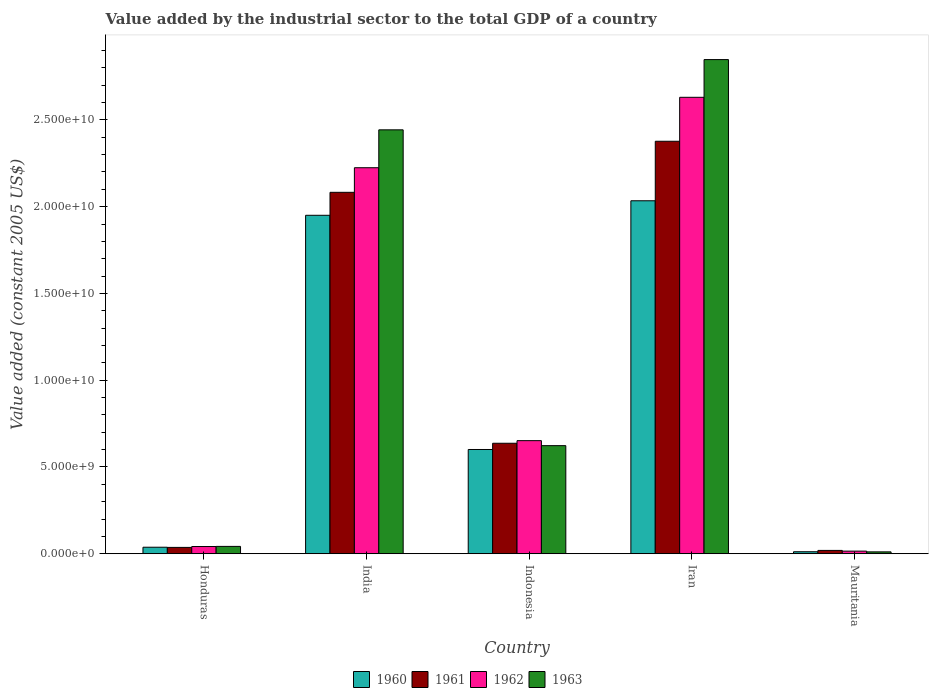How many groups of bars are there?
Provide a succinct answer. 5. Are the number of bars per tick equal to the number of legend labels?
Give a very brief answer. Yes. In how many cases, is the number of bars for a given country not equal to the number of legend labels?
Ensure brevity in your answer.  0. What is the value added by the industrial sector in 1961 in Iran?
Offer a very short reply. 2.38e+1. Across all countries, what is the maximum value added by the industrial sector in 1963?
Your answer should be compact. 2.85e+1. Across all countries, what is the minimum value added by the industrial sector in 1961?
Give a very brief answer. 1.92e+08. In which country was the value added by the industrial sector in 1963 maximum?
Keep it short and to the point. Iran. In which country was the value added by the industrial sector in 1963 minimum?
Offer a very short reply. Mauritania. What is the total value added by the industrial sector in 1962 in the graph?
Make the answer very short. 5.56e+1. What is the difference between the value added by the industrial sector in 1963 in India and that in Indonesia?
Ensure brevity in your answer.  1.82e+1. What is the difference between the value added by the industrial sector in 1961 in Indonesia and the value added by the industrial sector in 1960 in Iran?
Your response must be concise. -1.40e+1. What is the average value added by the industrial sector in 1961 per country?
Provide a short and direct response. 1.03e+1. What is the difference between the value added by the industrial sector of/in 1960 and value added by the industrial sector of/in 1961 in Honduras?
Your answer should be very brief. 9.37e+06. What is the ratio of the value added by the industrial sector in 1962 in Honduras to that in India?
Give a very brief answer. 0.02. What is the difference between the highest and the second highest value added by the industrial sector in 1961?
Offer a very short reply. -2.94e+09. What is the difference between the highest and the lowest value added by the industrial sector in 1963?
Give a very brief answer. 2.84e+1. Is the sum of the value added by the industrial sector in 1962 in Honduras and Iran greater than the maximum value added by the industrial sector in 1961 across all countries?
Make the answer very short. Yes. Is it the case that in every country, the sum of the value added by the industrial sector in 1961 and value added by the industrial sector in 1960 is greater than the sum of value added by the industrial sector in 1962 and value added by the industrial sector in 1963?
Make the answer very short. No. How many bars are there?
Your answer should be very brief. 20. Are the values on the major ticks of Y-axis written in scientific E-notation?
Give a very brief answer. Yes. Does the graph contain grids?
Provide a short and direct response. No. How many legend labels are there?
Ensure brevity in your answer.  4. What is the title of the graph?
Provide a short and direct response. Value added by the industrial sector to the total GDP of a country. What is the label or title of the X-axis?
Keep it short and to the point. Country. What is the label or title of the Y-axis?
Keep it short and to the point. Value added (constant 2005 US$). What is the Value added (constant 2005 US$) of 1960 in Honduras?
Your answer should be compact. 3.75e+08. What is the Value added (constant 2005 US$) of 1961 in Honduras?
Ensure brevity in your answer.  3.66e+08. What is the Value added (constant 2005 US$) in 1962 in Honduras?
Ensure brevity in your answer.  4.16e+08. What is the Value added (constant 2005 US$) of 1963 in Honduras?
Provide a short and direct response. 4.23e+08. What is the Value added (constant 2005 US$) in 1960 in India?
Your answer should be very brief. 1.95e+1. What is the Value added (constant 2005 US$) in 1961 in India?
Offer a very short reply. 2.08e+1. What is the Value added (constant 2005 US$) in 1962 in India?
Offer a very short reply. 2.22e+1. What is the Value added (constant 2005 US$) in 1963 in India?
Make the answer very short. 2.44e+1. What is the Value added (constant 2005 US$) of 1960 in Indonesia?
Provide a succinct answer. 6.01e+09. What is the Value added (constant 2005 US$) of 1961 in Indonesia?
Ensure brevity in your answer.  6.37e+09. What is the Value added (constant 2005 US$) in 1962 in Indonesia?
Provide a succinct answer. 6.52e+09. What is the Value added (constant 2005 US$) of 1963 in Indonesia?
Give a very brief answer. 6.23e+09. What is the Value added (constant 2005 US$) in 1960 in Iran?
Your response must be concise. 2.03e+1. What is the Value added (constant 2005 US$) in 1961 in Iran?
Provide a succinct answer. 2.38e+1. What is the Value added (constant 2005 US$) of 1962 in Iran?
Ensure brevity in your answer.  2.63e+1. What is the Value added (constant 2005 US$) of 1963 in Iran?
Keep it short and to the point. 2.85e+1. What is the Value added (constant 2005 US$) in 1960 in Mauritania?
Provide a short and direct response. 1.15e+08. What is the Value added (constant 2005 US$) in 1961 in Mauritania?
Ensure brevity in your answer.  1.92e+08. What is the Value added (constant 2005 US$) of 1962 in Mauritania?
Your answer should be very brief. 1.51e+08. What is the Value added (constant 2005 US$) in 1963 in Mauritania?
Your answer should be very brief. 1.08e+08. Across all countries, what is the maximum Value added (constant 2005 US$) in 1960?
Provide a short and direct response. 2.03e+1. Across all countries, what is the maximum Value added (constant 2005 US$) of 1961?
Your response must be concise. 2.38e+1. Across all countries, what is the maximum Value added (constant 2005 US$) of 1962?
Keep it short and to the point. 2.63e+1. Across all countries, what is the maximum Value added (constant 2005 US$) in 1963?
Make the answer very short. 2.85e+1. Across all countries, what is the minimum Value added (constant 2005 US$) in 1960?
Your answer should be compact. 1.15e+08. Across all countries, what is the minimum Value added (constant 2005 US$) of 1961?
Provide a succinct answer. 1.92e+08. Across all countries, what is the minimum Value added (constant 2005 US$) in 1962?
Provide a short and direct response. 1.51e+08. Across all countries, what is the minimum Value added (constant 2005 US$) of 1963?
Keep it short and to the point. 1.08e+08. What is the total Value added (constant 2005 US$) in 1960 in the graph?
Offer a terse response. 4.63e+1. What is the total Value added (constant 2005 US$) of 1961 in the graph?
Offer a terse response. 5.15e+1. What is the total Value added (constant 2005 US$) of 1962 in the graph?
Make the answer very short. 5.56e+1. What is the total Value added (constant 2005 US$) of 1963 in the graph?
Provide a short and direct response. 5.97e+1. What is the difference between the Value added (constant 2005 US$) of 1960 in Honduras and that in India?
Your answer should be very brief. -1.91e+1. What is the difference between the Value added (constant 2005 US$) of 1961 in Honduras and that in India?
Offer a very short reply. -2.05e+1. What is the difference between the Value added (constant 2005 US$) of 1962 in Honduras and that in India?
Provide a short and direct response. -2.18e+1. What is the difference between the Value added (constant 2005 US$) of 1963 in Honduras and that in India?
Your answer should be very brief. -2.40e+1. What is the difference between the Value added (constant 2005 US$) of 1960 in Honduras and that in Indonesia?
Give a very brief answer. -5.63e+09. What is the difference between the Value added (constant 2005 US$) in 1961 in Honduras and that in Indonesia?
Your answer should be compact. -6.00e+09. What is the difference between the Value added (constant 2005 US$) in 1962 in Honduras and that in Indonesia?
Provide a short and direct response. -6.10e+09. What is the difference between the Value added (constant 2005 US$) of 1963 in Honduras and that in Indonesia?
Keep it short and to the point. -5.81e+09. What is the difference between the Value added (constant 2005 US$) of 1960 in Honduras and that in Iran?
Give a very brief answer. -2.00e+1. What is the difference between the Value added (constant 2005 US$) of 1961 in Honduras and that in Iran?
Your response must be concise. -2.34e+1. What is the difference between the Value added (constant 2005 US$) in 1962 in Honduras and that in Iran?
Your answer should be compact. -2.59e+1. What is the difference between the Value added (constant 2005 US$) in 1963 in Honduras and that in Iran?
Provide a succinct answer. -2.81e+1. What is the difference between the Value added (constant 2005 US$) in 1960 in Honduras and that in Mauritania?
Provide a succinct answer. 2.60e+08. What is the difference between the Value added (constant 2005 US$) in 1961 in Honduras and that in Mauritania?
Your answer should be very brief. 1.74e+08. What is the difference between the Value added (constant 2005 US$) of 1962 in Honduras and that in Mauritania?
Your response must be concise. 2.65e+08. What is the difference between the Value added (constant 2005 US$) of 1963 in Honduras and that in Mauritania?
Offer a very short reply. 3.15e+08. What is the difference between the Value added (constant 2005 US$) of 1960 in India and that in Indonesia?
Your answer should be very brief. 1.35e+1. What is the difference between the Value added (constant 2005 US$) in 1961 in India and that in Indonesia?
Keep it short and to the point. 1.45e+1. What is the difference between the Value added (constant 2005 US$) in 1962 in India and that in Indonesia?
Give a very brief answer. 1.57e+1. What is the difference between the Value added (constant 2005 US$) of 1963 in India and that in Indonesia?
Your answer should be compact. 1.82e+1. What is the difference between the Value added (constant 2005 US$) in 1960 in India and that in Iran?
Your answer should be compact. -8.36e+08. What is the difference between the Value added (constant 2005 US$) in 1961 in India and that in Iran?
Your answer should be very brief. -2.94e+09. What is the difference between the Value added (constant 2005 US$) in 1962 in India and that in Iran?
Ensure brevity in your answer.  -4.06e+09. What is the difference between the Value added (constant 2005 US$) of 1963 in India and that in Iran?
Offer a terse response. -4.05e+09. What is the difference between the Value added (constant 2005 US$) of 1960 in India and that in Mauritania?
Offer a very short reply. 1.94e+1. What is the difference between the Value added (constant 2005 US$) of 1961 in India and that in Mauritania?
Make the answer very short. 2.06e+1. What is the difference between the Value added (constant 2005 US$) of 1962 in India and that in Mauritania?
Offer a terse response. 2.21e+1. What is the difference between the Value added (constant 2005 US$) of 1963 in India and that in Mauritania?
Provide a succinct answer. 2.43e+1. What is the difference between the Value added (constant 2005 US$) of 1960 in Indonesia and that in Iran?
Make the answer very short. -1.43e+1. What is the difference between the Value added (constant 2005 US$) of 1961 in Indonesia and that in Iran?
Ensure brevity in your answer.  -1.74e+1. What is the difference between the Value added (constant 2005 US$) in 1962 in Indonesia and that in Iran?
Your answer should be compact. -1.98e+1. What is the difference between the Value added (constant 2005 US$) in 1963 in Indonesia and that in Iran?
Provide a short and direct response. -2.22e+1. What is the difference between the Value added (constant 2005 US$) of 1960 in Indonesia and that in Mauritania?
Your response must be concise. 5.89e+09. What is the difference between the Value added (constant 2005 US$) of 1961 in Indonesia and that in Mauritania?
Make the answer very short. 6.17e+09. What is the difference between the Value added (constant 2005 US$) in 1962 in Indonesia and that in Mauritania?
Your answer should be very brief. 6.37e+09. What is the difference between the Value added (constant 2005 US$) in 1963 in Indonesia and that in Mauritania?
Your response must be concise. 6.12e+09. What is the difference between the Value added (constant 2005 US$) of 1960 in Iran and that in Mauritania?
Your answer should be very brief. 2.02e+1. What is the difference between the Value added (constant 2005 US$) of 1961 in Iran and that in Mauritania?
Ensure brevity in your answer.  2.36e+1. What is the difference between the Value added (constant 2005 US$) in 1962 in Iran and that in Mauritania?
Provide a short and direct response. 2.62e+1. What is the difference between the Value added (constant 2005 US$) of 1963 in Iran and that in Mauritania?
Ensure brevity in your answer.  2.84e+1. What is the difference between the Value added (constant 2005 US$) of 1960 in Honduras and the Value added (constant 2005 US$) of 1961 in India?
Your response must be concise. -2.05e+1. What is the difference between the Value added (constant 2005 US$) of 1960 in Honduras and the Value added (constant 2005 US$) of 1962 in India?
Provide a succinct answer. -2.19e+1. What is the difference between the Value added (constant 2005 US$) of 1960 in Honduras and the Value added (constant 2005 US$) of 1963 in India?
Keep it short and to the point. -2.41e+1. What is the difference between the Value added (constant 2005 US$) in 1961 in Honduras and the Value added (constant 2005 US$) in 1962 in India?
Offer a very short reply. -2.19e+1. What is the difference between the Value added (constant 2005 US$) in 1961 in Honduras and the Value added (constant 2005 US$) in 1963 in India?
Keep it short and to the point. -2.41e+1. What is the difference between the Value added (constant 2005 US$) of 1962 in Honduras and the Value added (constant 2005 US$) of 1963 in India?
Ensure brevity in your answer.  -2.40e+1. What is the difference between the Value added (constant 2005 US$) of 1960 in Honduras and the Value added (constant 2005 US$) of 1961 in Indonesia?
Your response must be concise. -5.99e+09. What is the difference between the Value added (constant 2005 US$) of 1960 in Honduras and the Value added (constant 2005 US$) of 1962 in Indonesia?
Provide a succinct answer. -6.14e+09. What is the difference between the Value added (constant 2005 US$) in 1960 in Honduras and the Value added (constant 2005 US$) in 1963 in Indonesia?
Keep it short and to the point. -5.85e+09. What is the difference between the Value added (constant 2005 US$) in 1961 in Honduras and the Value added (constant 2005 US$) in 1962 in Indonesia?
Your answer should be compact. -6.15e+09. What is the difference between the Value added (constant 2005 US$) in 1961 in Honduras and the Value added (constant 2005 US$) in 1963 in Indonesia?
Your response must be concise. -5.86e+09. What is the difference between the Value added (constant 2005 US$) of 1962 in Honduras and the Value added (constant 2005 US$) of 1963 in Indonesia?
Your answer should be very brief. -5.81e+09. What is the difference between the Value added (constant 2005 US$) of 1960 in Honduras and the Value added (constant 2005 US$) of 1961 in Iran?
Your response must be concise. -2.34e+1. What is the difference between the Value added (constant 2005 US$) of 1960 in Honduras and the Value added (constant 2005 US$) of 1962 in Iran?
Your answer should be compact. -2.59e+1. What is the difference between the Value added (constant 2005 US$) of 1960 in Honduras and the Value added (constant 2005 US$) of 1963 in Iran?
Offer a terse response. -2.81e+1. What is the difference between the Value added (constant 2005 US$) of 1961 in Honduras and the Value added (constant 2005 US$) of 1962 in Iran?
Give a very brief answer. -2.59e+1. What is the difference between the Value added (constant 2005 US$) in 1961 in Honduras and the Value added (constant 2005 US$) in 1963 in Iran?
Give a very brief answer. -2.81e+1. What is the difference between the Value added (constant 2005 US$) of 1962 in Honduras and the Value added (constant 2005 US$) of 1963 in Iran?
Offer a terse response. -2.81e+1. What is the difference between the Value added (constant 2005 US$) in 1960 in Honduras and the Value added (constant 2005 US$) in 1961 in Mauritania?
Keep it short and to the point. 1.83e+08. What is the difference between the Value added (constant 2005 US$) in 1960 in Honduras and the Value added (constant 2005 US$) in 1962 in Mauritania?
Offer a very short reply. 2.24e+08. What is the difference between the Value added (constant 2005 US$) in 1960 in Honduras and the Value added (constant 2005 US$) in 1963 in Mauritania?
Your answer should be compact. 2.67e+08. What is the difference between the Value added (constant 2005 US$) of 1961 in Honduras and the Value added (constant 2005 US$) of 1962 in Mauritania?
Keep it short and to the point. 2.15e+08. What is the difference between the Value added (constant 2005 US$) in 1961 in Honduras and the Value added (constant 2005 US$) in 1963 in Mauritania?
Your answer should be compact. 2.58e+08. What is the difference between the Value added (constant 2005 US$) in 1962 in Honduras and the Value added (constant 2005 US$) in 1963 in Mauritania?
Make the answer very short. 3.08e+08. What is the difference between the Value added (constant 2005 US$) in 1960 in India and the Value added (constant 2005 US$) in 1961 in Indonesia?
Give a very brief answer. 1.31e+1. What is the difference between the Value added (constant 2005 US$) in 1960 in India and the Value added (constant 2005 US$) in 1962 in Indonesia?
Provide a succinct answer. 1.30e+1. What is the difference between the Value added (constant 2005 US$) in 1960 in India and the Value added (constant 2005 US$) in 1963 in Indonesia?
Keep it short and to the point. 1.33e+1. What is the difference between the Value added (constant 2005 US$) of 1961 in India and the Value added (constant 2005 US$) of 1962 in Indonesia?
Give a very brief answer. 1.43e+1. What is the difference between the Value added (constant 2005 US$) of 1961 in India and the Value added (constant 2005 US$) of 1963 in Indonesia?
Provide a succinct answer. 1.46e+1. What is the difference between the Value added (constant 2005 US$) of 1962 in India and the Value added (constant 2005 US$) of 1963 in Indonesia?
Your response must be concise. 1.60e+1. What is the difference between the Value added (constant 2005 US$) in 1960 in India and the Value added (constant 2005 US$) in 1961 in Iran?
Keep it short and to the point. -4.27e+09. What is the difference between the Value added (constant 2005 US$) of 1960 in India and the Value added (constant 2005 US$) of 1962 in Iran?
Offer a very short reply. -6.80e+09. What is the difference between the Value added (constant 2005 US$) in 1960 in India and the Value added (constant 2005 US$) in 1963 in Iran?
Your answer should be compact. -8.97e+09. What is the difference between the Value added (constant 2005 US$) of 1961 in India and the Value added (constant 2005 US$) of 1962 in Iran?
Provide a succinct answer. -5.48e+09. What is the difference between the Value added (constant 2005 US$) of 1961 in India and the Value added (constant 2005 US$) of 1963 in Iran?
Provide a short and direct response. -7.65e+09. What is the difference between the Value added (constant 2005 US$) of 1962 in India and the Value added (constant 2005 US$) of 1963 in Iran?
Provide a short and direct response. -6.23e+09. What is the difference between the Value added (constant 2005 US$) of 1960 in India and the Value added (constant 2005 US$) of 1961 in Mauritania?
Offer a very short reply. 1.93e+1. What is the difference between the Value added (constant 2005 US$) in 1960 in India and the Value added (constant 2005 US$) in 1962 in Mauritania?
Ensure brevity in your answer.  1.94e+1. What is the difference between the Value added (constant 2005 US$) of 1960 in India and the Value added (constant 2005 US$) of 1963 in Mauritania?
Ensure brevity in your answer.  1.94e+1. What is the difference between the Value added (constant 2005 US$) in 1961 in India and the Value added (constant 2005 US$) in 1962 in Mauritania?
Make the answer very short. 2.07e+1. What is the difference between the Value added (constant 2005 US$) in 1961 in India and the Value added (constant 2005 US$) in 1963 in Mauritania?
Make the answer very short. 2.07e+1. What is the difference between the Value added (constant 2005 US$) of 1962 in India and the Value added (constant 2005 US$) of 1963 in Mauritania?
Provide a short and direct response. 2.21e+1. What is the difference between the Value added (constant 2005 US$) of 1960 in Indonesia and the Value added (constant 2005 US$) of 1961 in Iran?
Give a very brief answer. -1.78e+1. What is the difference between the Value added (constant 2005 US$) in 1960 in Indonesia and the Value added (constant 2005 US$) in 1962 in Iran?
Provide a succinct answer. -2.03e+1. What is the difference between the Value added (constant 2005 US$) of 1960 in Indonesia and the Value added (constant 2005 US$) of 1963 in Iran?
Offer a terse response. -2.25e+1. What is the difference between the Value added (constant 2005 US$) in 1961 in Indonesia and the Value added (constant 2005 US$) in 1962 in Iran?
Your answer should be very brief. -1.99e+1. What is the difference between the Value added (constant 2005 US$) in 1961 in Indonesia and the Value added (constant 2005 US$) in 1963 in Iran?
Your response must be concise. -2.21e+1. What is the difference between the Value added (constant 2005 US$) of 1962 in Indonesia and the Value added (constant 2005 US$) of 1963 in Iran?
Ensure brevity in your answer.  -2.20e+1. What is the difference between the Value added (constant 2005 US$) of 1960 in Indonesia and the Value added (constant 2005 US$) of 1961 in Mauritania?
Your answer should be compact. 5.81e+09. What is the difference between the Value added (constant 2005 US$) in 1960 in Indonesia and the Value added (constant 2005 US$) in 1962 in Mauritania?
Provide a succinct answer. 5.86e+09. What is the difference between the Value added (constant 2005 US$) of 1960 in Indonesia and the Value added (constant 2005 US$) of 1963 in Mauritania?
Provide a short and direct response. 5.90e+09. What is the difference between the Value added (constant 2005 US$) in 1961 in Indonesia and the Value added (constant 2005 US$) in 1962 in Mauritania?
Your response must be concise. 6.22e+09. What is the difference between the Value added (constant 2005 US$) of 1961 in Indonesia and the Value added (constant 2005 US$) of 1963 in Mauritania?
Your response must be concise. 6.26e+09. What is the difference between the Value added (constant 2005 US$) of 1962 in Indonesia and the Value added (constant 2005 US$) of 1963 in Mauritania?
Provide a short and direct response. 6.41e+09. What is the difference between the Value added (constant 2005 US$) in 1960 in Iran and the Value added (constant 2005 US$) in 1961 in Mauritania?
Your answer should be compact. 2.01e+1. What is the difference between the Value added (constant 2005 US$) in 1960 in Iran and the Value added (constant 2005 US$) in 1962 in Mauritania?
Offer a very short reply. 2.02e+1. What is the difference between the Value added (constant 2005 US$) in 1960 in Iran and the Value added (constant 2005 US$) in 1963 in Mauritania?
Keep it short and to the point. 2.02e+1. What is the difference between the Value added (constant 2005 US$) of 1961 in Iran and the Value added (constant 2005 US$) of 1962 in Mauritania?
Offer a very short reply. 2.36e+1. What is the difference between the Value added (constant 2005 US$) in 1961 in Iran and the Value added (constant 2005 US$) in 1963 in Mauritania?
Make the answer very short. 2.37e+1. What is the difference between the Value added (constant 2005 US$) in 1962 in Iran and the Value added (constant 2005 US$) in 1963 in Mauritania?
Offer a terse response. 2.62e+1. What is the average Value added (constant 2005 US$) in 1960 per country?
Make the answer very short. 9.27e+09. What is the average Value added (constant 2005 US$) in 1961 per country?
Give a very brief answer. 1.03e+1. What is the average Value added (constant 2005 US$) of 1962 per country?
Provide a short and direct response. 1.11e+1. What is the average Value added (constant 2005 US$) of 1963 per country?
Your answer should be very brief. 1.19e+1. What is the difference between the Value added (constant 2005 US$) in 1960 and Value added (constant 2005 US$) in 1961 in Honduras?
Your answer should be compact. 9.37e+06. What is the difference between the Value added (constant 2005 US$) of 1960 and Value added (constant 2005 US$) of 1962 in Honduras?
Your response must be concise. -4.07e+07. What is the difference between the Value added (constant 2005 US$) of 1960 and Value added (constant 2005 US$) of 1963 in Honduras?
Ensure brevity in your answer.  -4.79e+07. What is the difference between the Value added (constant 2005 US$) of 1961 and Value added (constant 2005 US$) of 1962 in Honduras?
Your answer should be very brief. -5.00e+07. What is the difference between the Value added (constant 2005 US$) in 1961 and Value added (constant 2005 US$) in 1963 in Honduras?
Ensure brevity in your answer.  -5.72e+07. What is the difference between the Value added (constant 2005 US$) in 1962 and Value added (constant 2005 US$) in 1963 in Honduras?
Provide a succinct answer. -7.19e+06. What is the difference between the Value added (constant 2005 US$) of 1960 and Value added (constant 2005 US$) of 1961 in India?
Give a very brief answer. -1.32e+09. What is the difference between the Value added (constant 2005 US$) in 1960 and Value added (constant 2005 US$) in 1962 in India?
Your answer should be very brief. -2.74e+09. What is the difference between the Value added (constant 2005 US$) in 1960 and Value added (constant 2005 US$) in 1963 in India?
Your response must be concise. -4.92e+09. What is the difference between the Value added (constant 2005 US$) of 1961 and Value added (constant 2005 US$) of 1962 in India?
Offer a very short reply. -1.42e+09. What is the difference between the Value added (constant 2005 US$) of 1961 and Value added (constant 2005 US$) of 1963 in India?
Keep it short and to the point. -3.60e+09. What is the difference between the Value added (constant 2005 US$) in 1962 and Value added (constant 2005 US$) in 1963 in India?
Ensure brevity in your answer.  -2.18e+09. What is the difference between the Value added (constant 2005 US$) of 1960 and Value added (constant 2005 US$) of 1961 in Indonesia?
Keep it short and to the point. -3.60e+08. What is the difference between the Value added (constant 2005 US$) of 1960 and Value added (constant 2005 US$) of 1962 in Indonesia?
Provide a succinct answer. -5.10e+08. What is the difference between the Value added (constant 2005 US$) of 1960 and Value added (constant 2005 US$) of 1963 in Indonesia?
Offer a very short reply. -2.22e+08. What is the difference between the Value added (constant 2005 US$) of 1961 and Value added (constant 2005 US$) of 1962 in Indonesia?
Provide a succinct answer. -1.50e+08. What is the difference between the Value added (constant 2005 US$) of 1961 and Value added (constant 2005 US$) of 1963 in Indonesia?
Provide a short and direct response. 1.38e+08. What is the difference between the Value added (constant 2005 US$) of 1962 and Value added (constant 2005 US$) of 1963 in Indonesia?
Your response must be concise. 2.88e+08. What is the difference between the Value added (constant 2005 US$) of 1960 and Value added (constant 2005 US$) of 1961 in Iran?
Make the answer very short. -3.43e+09. What is the difference between the Value added (constant 2005 US$) of 1960 and Value added (constant 2005 US$) of 1962 in Iran?
Provide a succinct answer. -5.96e+09. What is the difference between the Value added (constant 2005 US$) of 1960 and Value added (constant 2005 US$) of 1963 in Iran?
Your answer should be very brief. -8.14e+09. What is the difference between the Value added (constant 2005 US$) in 1961 and Value added (constant 2005 US$) in 1962 in Iran?
Ensure brevity in your answer.  -2.53e+09. What is the difference between the Value added (constant 2005 US$) in 1961 and Value added (constant 2005 US$) in 1963 in Iran?
Offer a terse response. -4.71e+09. What is the difference between the Value added (constant 2005 US$) of 1962 and Value added (constant 2005 US$) of 1963 in Iran?
Ensure brevity in your answer.  -2.17e+09. What is the difference between the Value added (constant 2005 US$) in 1960 and Value added (constant 2005 US$) in 1961 in Mauritania?
Ensure brevity in your answer.  -7.68e+07. What is the difference between the Value added (constant 2005 US$) of 1960 and Value added (constant 2005 US$) of 1962 in Mauritania?
Offer a terse response. -3.59e+07. What is the difference between the Value added (constant 2005 US$) of 1960 and Value added (constant 2005 US$) of 1963 in Mauritania?
Ensure brevity in your answer.  7.13e+06. What is the difference between the Value added (constant 2005 US$) in 1961 and Value added (constant 2005 US$) in 1962 in Mauritania?
Provide a short and direct response. 4.09e+07. What is the difference between the Value added (constant 2005 US$) in 1961 and Value added (constant 2005 US$) in 1963 in Mauritania?
Keep it short and to the point. 8.39e+07. What is the difference between the Value added (constant 2005 US$) of 1962 and Value added (constant 2005 US$) of 1963 in Mauritania?
Provide a short and direct response. 4.31e+07. What is the ratio of the Value added (constant 2005 US$) in 1960 in Honduras to that in India?
Keep it short and to the point. 0.02. What is the ratio of the Value added (constant 2005 US$) in 1961 in Honduras to that in India?
Your answer should be compact. 0.02. What is the ratio of the Value added (constant 2005 US$) in 1962 in Honduras to that in India?
Provide a short and direct response. 0.02. What is the ratio of the Value added (constant 2005 US$) in 1963 in Honduras to that in India?
Give a very brief answer. 0.02. What is the ratio of the Value added (constant 2005 US$) in 1960 in Honduras to that in Indonesia?
Your answer should be compact. 0.06. What is the ratio of the Value added (constant 2005 US$) in 1961 in Honduras to that in Indonesia?
Your answer should be compact. 0.06. What is the ratio of the Value added (constant 2005 US$) of 1962 in Honduras to that in Indonesia?
Ensure brevity in your answer.  0.06. What is the ratio of the Value added (constant 2005 US$) of 1963 in Honduras to that in Indonesia?
Provide a succinct answer. 0.07. What is the ratio of the Value added (constant 2005 US$) in 1960 in Honduras to that in Iran?
Provide a short and direct response. 0.02. What is the ratio of the Value added (constant 2005 US$) in 1961 in Honduras to that in Iran?
Offer a very short reply. 0.02. What is the ratio of the Value added (constant 2005 US$) of 1962 in Honduras to that in Iran?
Give a very brief answer. 0.02. What is the ratio of the Value added (constant 2005 US$) in 1963 in Honduras to that in Iran?
Offer a very short reply. 0.01. What is the ratio of the Value added (constant 2005 US$) of 1960 in Honduras to that in Mauritania?
Make the answer very short. 3.25. What is the ratio of the Value added (constant 2005 US$) of 1961 in Honduras to that in Mauritania?
Give a very brief answer. 1.9. What is the ratio of the Value added (constant 2005 US$) in 1962 in Honduras to that in Mauritania?
Provide a short and direct response. 2.75. What is the ratio of the Value added (constant 2005 US$) of 1963 in Honduras to that in Mauritania?
Your response must be concise. 3.91. What is the ratio of the Value added (constant 2005 US$) in 1960 in India to that in Indonesia?
Offer a very short reply. 3.25. What is the ratio of the Value added (constant 2005 US$) of 1961 in India to that in Indonesia?
Keep it short and to the point. 3.27. What is the ratio of the Value added (constant 2005 US$) in 1962 in India to that in Indonesia?
Your answer should be very brief. 3.41. What is the ratio of the Value added (constant 2005 US$) of 1963 in India to that in Indonesia?
Offer a terse response. 3.92. What is the ratio of the Value added (constant 2005 US$) in 1960 in India to that in Iran?
Your answer should be very brief. 0.96. What is the ratio of the Value added (constant 2005 US$) of 1961 in India to that in Iran?
Provide a short and direct response. 0.88. What is the ratio of the Value added (constant 2005 US$) of 1962 in India to that in Iran?
Provide a succinct answer. 0.85. What is the ratio of the Value added (constant 2005 US$) in 1963 in India to that in Iran?
Offer a very short reply. 0.86. What is the ratio of the Value added (constant 2005 US$) in 1960 in India to that in Mauritania?
Ensure brevity in your answer.  169.07. What is the ratio of the Value added (constant 2005 US$) in 1961 in India to that in Mauritania?
Your answer should be very brief. 108.39. What is the ratio of the Value added (constant 2005 US$) of 1962 in India to that in Mauritania?
Ensure brevity in your answer.  147.02. What is the ratio of the Value added (constant 2005 US$) in 1963 in India to that in Mauritania?
Keep it short and to the point. 225.7. What is the ratio of the Value added (constant 2005 US$) of 1960 in Indonesia to that in Iran?
Offer a terse response. 0.3. What is the ratio of the Value added (constant 2005 US$) in 1961 in Indonesia to that in Iran?
Keep it short and to the point. 0.27. What is the ratio of the Value added (constant 2005 US$) in 1962 in Indonesia to that in Iran?
Give a very brief answer. 0.25. What is the ratio of the Value added (constant 2005 US$) of 1963 in Indonesia to that in Iran?
Your answer should be very brief. 0.22. What is the ratio of the Value added (constant 2005 US$) of 1960 in Indonesia to that in Mauritania?
Your response must be concise. 52.07. What is the ratio of the Value added (constant 2005 US$) of 1961 in Indonesia to that in Mauritania?
Offer a very short reply. 33.14. What is the ratio of the Value added (constant 2005 US$) in 1962 in Indonesia to that in Mauritania?
Your answer should be very brief. 43.07. What is the ratio of the Value added (constant 2005 US$) in 1963 in Indonesia to that in Mauritania?
Your response must be concise. 57.56. What is the ratio of the Value added (constant 2005 US$) in 1960 in Iran to that in Mauritania?
Provide a short and direct response. 176.32. What is the ratio of the Value added (constant 2005 US$) of 1961 in Iran to that in Mauritania?
Provide a succinct answer. 123.7. What is the ratio of the Value added (constant 2005 US$) of 1962 in Iran to that in Mauritania?
Ensure brevity in your answer.  173.84. What is the ratio of the Value added (constant 2005 US$) in 1963 in Iran to that in Mauritania?
Offer a very short reply. 263.11. What is the difference between the highest and the second highest Value added (constant 2005 US$) of 1960?
Offer a very short reply. 8.36e+08. What is the difference between the highest and the second highest Value added (constant 2005 US$) in 1961?
Keep it short and to the point. 2.94e+09. What is the difference between the highest and the second highest Value added (constant 2005 US$) in 1962?
Offer a terse response. 4.06e+09. What is the difference between the highest and the second highest Value added (constant 2005 US$) of 1963?
Provide a short and direct response. 4.05e+09. What is the difference between the highest and the lowest Value added (constant 2005 US$) of 1960?
Ensure brevity in your answer.  2.02e+1. What is the difference between the highest and the lowest Value added (constant 2005 US$) in 1961?
Offer a terse response. 2.36e+1. What is the difference between the highest and the lowest Value added (constant 2005 US$) in 1962?
Make the answer very short. 2.62e+1. What is the difference between the highest and the lowest Value added (constant 2005 US$) in 1963?
Provide a short and direct response. 2.84e+1. 